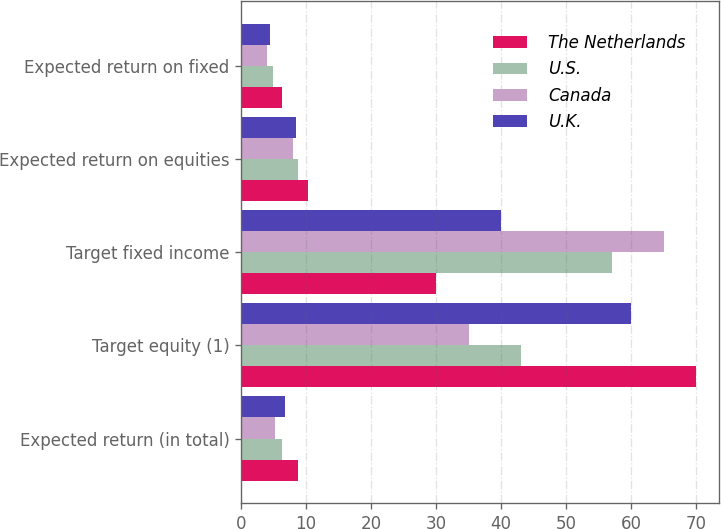<chart> <loc_0><loc_0><loc_500><loc_500><stacked_bar_chart><ecel><fcel>Expected return (in total)<fcel>Target equity (1)<fcel>Target fixed income<fcel>Expected return on equities<fcel>Expected return on fixed<nl><fcel>The Netherlands<fcel>8.8<fcel>70<fcel>30<fcel>10.3<fcel>6.3<nl><fcel>U.S.<fcel>6.3<fcel>43<fcel>57<fcel>8.7<fcel>4.9<nl><fcel>Canada<fcel>5.2<fcel>35<fcel>65<fcel>8<fcel>4<nl><fcel>U.K.<fcel>6.8<fcel>60<fcel>40<fcel>8.5<fcel>4.5<nl></chart> 